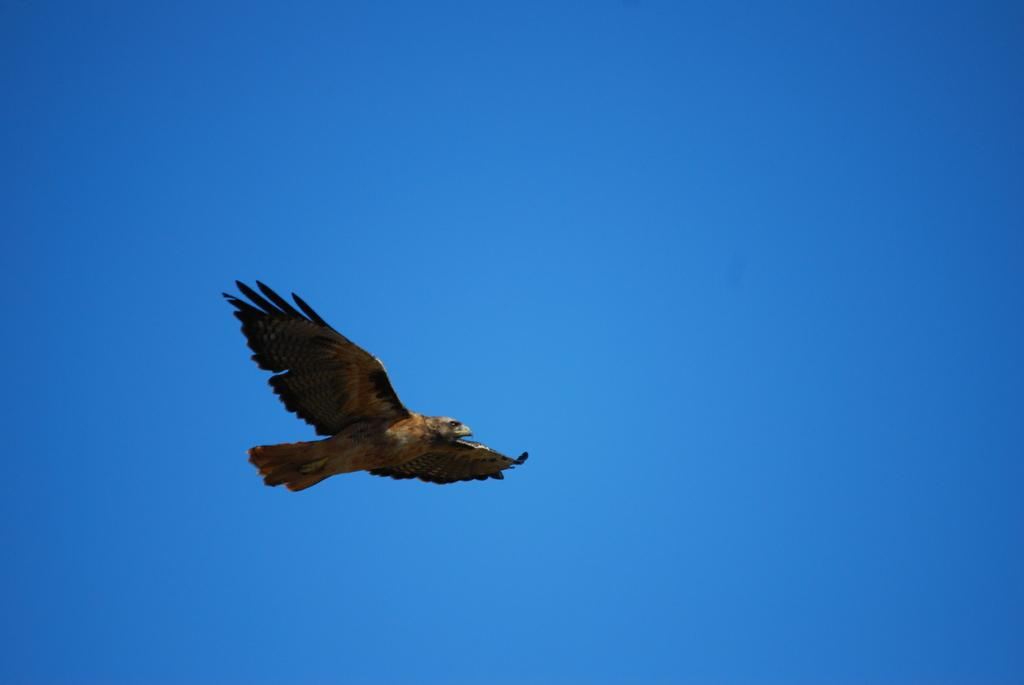What animal can be seen in the picture? There is an eagle in the picture. What is the eagle doing in the picture? The eagle is flying in the sky. Where is the baseball located in the image? There is no baseball present in the image. What type of throne is the eagle sitting on in the image? There is no throne present in the image, as the eagle is flying in the sky. 